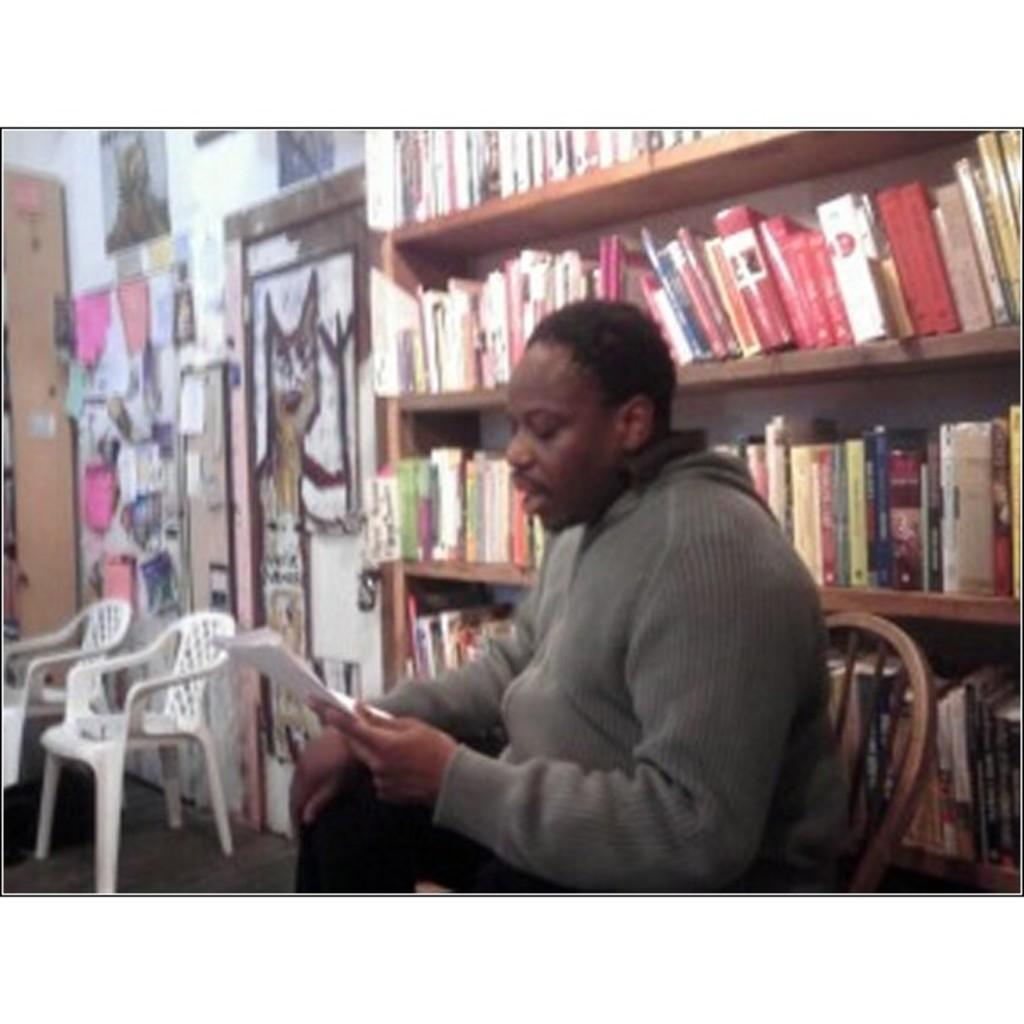What is the man in the image doing? The man is sitting in the middle of the image and reading a paper. What is the man holding in the image? The man is holding a paper. What can be seen behind the man in the image? There is a bookshelf behind the man. How many chairs are visible in the bottom left side of the image? There are two chairs in the bottom left side of the image. What is the man's belief about the value of the expert's opinion in the image? There is no information about the man's beliefs or the expert's opinion in the image. 